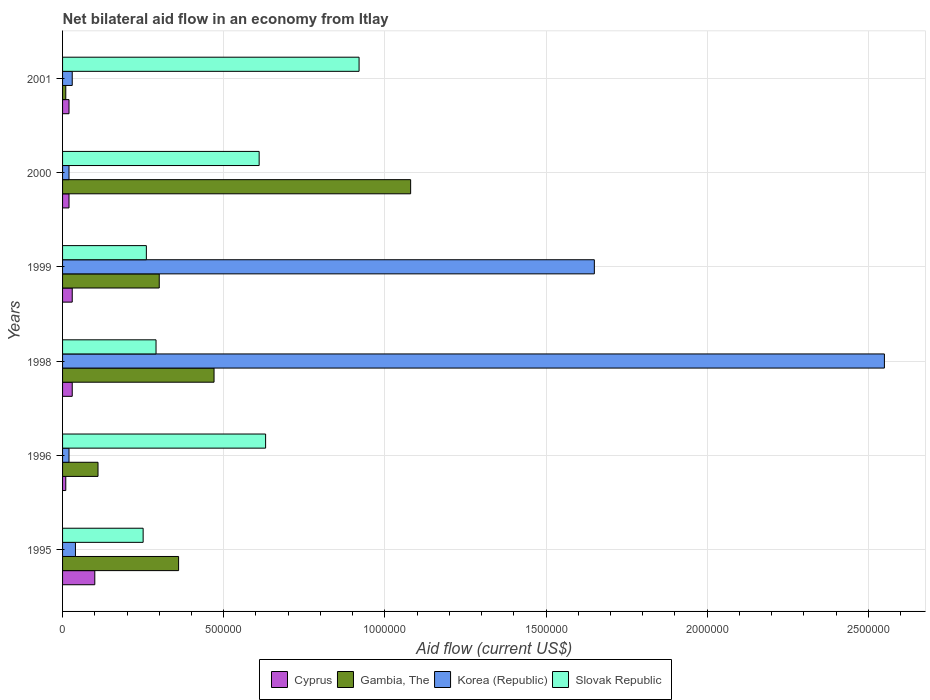How many groups of bars are there?
Make the answer very short. 6. Are the number of bars per tick equal to the number of legend labels?
Your answer should be very brief. Yes. What is the net bilateral aid flow in Cyprus in 1995?
Provide a short and direct response. 1.00e+05. Across all years, what is the maximum net bilateral aid flow in Slovak Republic?
Offer a terse response. 9.20e+05. In which year was the net bilateral aid flow in Korea (Republic) minimum?
Provide a short and direct response. 1996. What is the total net bilateral aid flow in Cyprus in the graph?
Keep it short and to the point. 2.10e+05. What is the difference between the net bilateral aid flow in Korea (Republic) in 1996 and that in 1998?
Your response must be concise. -2.53e+06. What is the difference between the net bilateral aid flow in Cyprus in 1998 and the net bilateral aid flow in Korea (Republic) in 1999?
Give a very brief answer. -1.62e+06. What is the average net bilateral aid flow in Korea (Republic) per year?
Keep it short and to the point. 7.18e+05. In the year 1996, what is the difference between the net bilateral aid flow in Cyprus and net bilateral aid flow in Gambia, The?
Your answer should be very brief. -1.00e+05. What is the difference between the highest and the lowest net bilateral aid flow in Gambia, The?
Offer a very short reply. 1.07e+06. In how many years, is the net bilateral aid flow in Slovak Republic greater than the average net bilateral aid flow in Slovak Republic taken over all years?
Offer a very short reply. 3. Is the sum of the net bilateral aid flow in Slovak Republic in 1996 and 1999 greater than the maximum net bilateral aid flow in Gambia, The across all years?
Your response must be concise. No. What does the 2nd bar from the top in 1995 represents?
Keep it short and to the point. Korea (Republic). What does the 4th bar from the bottom in 1995 represents?
Your answer should be very brief. Slovak Republic. How many bars are there?
Your answer should be compact. 24. Does the graph contain any zero values?
Give a very brief answer. No. Where does the legend appear in the graph?
Make the answer very short. Bottom center. How many legend labels are there?
Keep it short and to the point. 4. What is the title of the graph?
Your answer should be compact. Net bilateral aid flow in an economy from Itlay. What is the Aid flow (current US$) in Korea (Republic) in 1995?
Your answer should be very brief. 4.00e+04. What is the Aid flow (current US$) in Slovak Republic in 1995?
Make the answer very short. 2.50e+05. What is the Aid flow (current US$) in Cyprus in 1996?
Offer a very short reply. 10000. What is the Aid flow (current US$) in Korea (Republic) in 1996?
Give a very brief answer. 2.00e+04. What is the Aid flow (current US$) of Slovak Republic in 1996?
Offer a very short reply. 6.30e+05. What is the Aid flow (current US$) of Korea (Republic) in 1998?
Your answer should be compact. 2.55e+06. What is the Aid flow (current US$) in Slovak Republic in 1998?
Make the answer very short. 2.90e+05. What is the Aid flow (current US$) of Cyprus in 1999?
Offer a very short reply. 3.00e+04. What is the Aid flow (current US$) of Gambia, The in 1999?
Ensure brevity in your answer.  3.00e+05. What is the Aid flow (current US$) in Korea (Republic) in 1999?
Offer a terse response. 1.65e+06. What is the Aid flow (current US$) of Slovak Republic in 1999?
Provide a succinct answer. 2.60e+05. What is the Aid flow (current US$) in Cyprus in 2000?
Provide a short and direct response. 2.00e+04. What is the Aid flow (current US$) in Gambia, The in 2000?
Make the answer very short. 1.08e+06. What is the Aid flow (current US$) in Slovak Republic in 2000?
Your answer should be compact. 6.10e+05. What is the Aid flow (current US$) of Korea (Republic) in 2001?
Your answer should be compact. 3.00e+04. What is the Aid flow (current US$) of Slovak Republic in 2001?
Offer a very short reply. 9.20e+05. Across all years, what is the maximum Aid flow (current US$) in Cyprus?
Offer a terse response. 1.00e+05. Across all years, what is the maximum Aid flow (current US$) of Gambia, The?
Provide a succinct answer. 1.08e+06. Across all years, what is the maximum Aid flow (current US$) of Korea (Republic)?
Offer a terse response. 2.55e+06. Across all years, what is the maximum Aid flow (current US$) in Slovak Republic?
Offer a very short reply. 9.20e+05. Across all years, what is the minimum Aid flow (current US$) in Cyprus?
Your response must be concise. 10000. Across all years, what is the minimum Aid flow (current US$) of Gambia, The?
Provide a short and direct response. 10000. Across all years, what is the minimum Aid flow (current US$) of Slovak Republic?
Offer a terse response. 2.50e+05. What is the total Aid flow (current US$) in Cyprus in the graph?
Keep it short and to the point. 2.10e+05. What is the total Aid flow (current US$) in Gambia, The in the graph?
Your answer should be very brief. 2.33e+06. What is the total Aid flow (current US$) in Korea (Republic) in the graph?
Offer a very short reply. 4.31e+06. What is the total Aid flow (current US$) in Slovak Republic in the graph?
Ensure brevity in your answer.  2.96e+06. What is the difference between the Aid flow (current US$) in Cyprus in 1995 and that in 1996?
Give a very brief answer. 9.00e+04. What is the difference between the Aid flow (current US$) of Korea (Republic) in 1995 and that in 1996?
Your answer should be very brief. 2.00e+04. What is the difference between the Aid flow (current US$) in Slovak Republic in 1995 and that in 1996?
Make the answer very short. -3.80e+05. What is the difference between the Aid flow (current US$) in Cyprus in 1995 and that in 1998?
Give a very brief answer. 7.00e+04. What is the difference between the Aid flow (current US$) in Gambia, The in 1995 and that in 1998?
Your answer should be compact. -1.10e+05. What is the difference between the Aid flow (current US$) of Korea (Republic) in 1995 and that in 1998?
Your answer should be compact. -2.51e+06. What is the difference between the Aid flow (current US$) in Cyprus in 1995 and that in 1999?
Your answer should be very brief. 7.00e+04. What is the difference between the Aid flow (current US$) of Gambia, The in 1995 and that in 1999?
Your answer should be very brief. 6.00e+04. What is the difference between the Aid flow (current US$) of Korea (Republic) in 1995 and that in 1999?
Give a very brief answer. -1.61e+06. What is the difference between the Aid flow (current US$) of Slovak Republic in 1995 and that in 1999?
Ensure brevity in your answer.  -10000. What is the difference between the Aid flow (current US$) in Gambia, The in 1995 and that in 2000?
Provide a short and direct response. -7.20e+05. What is the difference between the Aid flow (current US$) in Korea (Republic) in 1995 and that in 2000?
Keep it short and to the point. 2.00e+04. What is the difference between the Aid flow (current US$) of Slovak Republic in 1995 and that in 2000?
Your answer should be very brief. -3.60e+05. What is the difference between the Aid flow (current US$) of Cyprus in 1995 and that in 2001?
Offer a very short reply. 8.00e+04. What is the difference between the Aid flow (current US$) of Gambia, The in 1995 and that in 2001?
Your answer should be very brief. 3.50e+05. What is the difference between the Aid flow (current US$) of Korea (Republic) in 1995 and that in 2001?
Provide a short and direct response. 10000. What is the difference between the Aid flow (current US$) in Slovak Republic in 1995 and that in 2001?
Provide a succinct answer. -6.70e+05. What is the difference between the Aid flow (current US$) of Cyprus in 1996 and that in 1998?
Give a very brief answer. -2.00e+04. What is the difference between the Aid flow (current US$) in Gambia, The in 1996 and that in 1998?
Offer a very short reply. -3.60e+05. What is the difference between the Aid flow (current US$) in Korea (Republic) in 1996 and that in 1998?
Keep it short and to the point. -2.53e+06. What is the difference between the Aid flow (current US$) in Korea (Republic) in 1996 and that in 1999?
Provide a succinct answer. -1.63e+06. What is the difference between the Aid flow (current US$) in Slovak Republic in 1996 and that in 1999?
Provide a short and direct response. 3.70e+05. What is the difference between the Aid flow (current US$) in Cyprus in 1996 and that in 2000?
Provide a short and direct response. -10000. What is the difference between the Aid flow (current US$) of Gambia, The in 1996 and that in 2000?
Make the answer very short. -9.70e+05. What is the difference between the Aid flow (current US$) in Korea (Republic) in 1996 and that in 2000?
Your answer should be compact. 0. What is the difference between the Aid flow (current US$) in Slovak Republic in 1996 and that in 2000?
Your answer should be compact. 2.00e+04. What is the difference between the Aid flow (current US$) of Cyprus in 1996 and that in 2001?
Provide a short and direct response. -10000. What is the difference between the Aid flow (current US$) in Gambia, The in 1996 and that in 2001?
Provide a succinct answer. 1.00e+05. What is the difference between the Aid flow (current US$) in Korea (Republic) in 1996 and that in 2001?
Your answer should be very brief. -10000. What is the difference between the Aid flow (current US$) of Gambia, The in 1998 and that in 1999?
Make the answer very short. 1.70e+05. What is the difference between the Aid flow (current US$) of Slovak Republic in 1998 and that in 1999?
Your answer should be very brief. 3.00e+04. What is the difference between the Aid flow (current US$) of Cyprus in 1998 and that in 2000?
Offer a terse response. 10000. What is the difference between the Aid flow (current US$) in Gambia, The in 1998 and that in 2000?
Your answer should be very brief. -6.10e+05. What is the difference between the Aid flow (current US$) in Korea (Republic) in 1998 and that in 2000?
Provide a short and direct response. 2.53e+06. What is the difference between the Aid flow (current US$) of Slovak Republic in 1998 and that in 2000?
Keep it short and to the point. -3.20e+05. What is the difference between the Aid flow (current US$) in Korea (Republic) in 1998 and that in 2001?
Provide a short and direct response. 2.52e+06. What is the difference between the Aid flow (current US$) in Slovak Republic in 1998 and that in 2001?
Provide a short and direct response. -6.30e+05. What is the difference between the Aid flow (current US$) in Cyprus in 1999 and that in 2000?
Provide a short and direct response. 10000. What is the difference between the Aid flow (current US$) of Gambia, The in 1999 and that in 2000?
Your answer should be very brief. -7.80e+05. What is the difference between the Aid flow (current US$) in Korea (Republic) in 1999 and that in 2000?
Ensure brevity in your answer.  1.63e+06. What is the difference between the Aid flow (current US$) of Slovak Republic in 1999 and that in 2000?
Offer a terse response. -3.50e+05. What is the difference between the Aid flow (current US$) of Cyprus in 1999 and that in 2001?
Your answer should be very brief. 10000. What is the difference between the Aid flow (current US$) in Gambia, The in 1999 and that in 2001?
Ensure brevity in your answer.  2.90e+05. What is the difference between the Aid flow (current US$) in Korea (Republic) in 1999 and that in 2001?
Your response must be concise. 1.62e+06. What is the difference between the Aid flow (current US$) in Slovak Republic in 1999 and that in 2001?
Ensure brevity in your answer.  -6.60e+05. What is the difference between the Aid flow (current US$) of Cyprus in 2000 and that in 2001?
Ensure brevity in your answer.  0. What is the difference between the Aid flow (current US$) in Gambia, The in 2000 and that in 2001?
Give a very brief answer. 1.07e+06. What is the difference between the Aid flow (current US$) in Slovak Republic in 2000 and that in 2001?
Your response must be concise. -3.10e+05. What is the difference between the Aid flow (current US$) of Cyprus in 1995 and the Aid flow (current US$) of Gambia, The in 1996?
Offer a terse response. -10000. What is the difference between the Aid flow (current US$) of Cyprus in 1995 and the Aid flow (current US$) of Korea (Republic) in 1996?
Your answer should be very brief. 8.00e+04. What is the difference between the Aid flow (current US$) of Cyprus in 1995 and the Aid flow (current US$) of Slovak Republic in 1996?
Your answer should be very brief. -5.30e+05. What is the difference between the Aid flow (current US$) of Gambia, The in 1995 and the Aid flow (current US$) of Korea (Republic) in 1996?
Provide a succinct answer. 3.40e+05. What is the difference between the Aid flow (current US$) of Korea (Republic) in 1995 and the Aid flow (current US$) of Slovak Republic in 1996?
Your response must be concise. -5.90e+05. What is the difference between the Aid flow (current US$) in Cyprus in 1995 and the Aid flow (current US$) in Gambia, The in 1998?
Offer a terse response. -3.70e+05. What is the difference between the Aid flow (current US$) of Cyprus in 1995 and the Aid flow (current US$) of Korea (Republic) in 1998?
Your answer should be very brief. -2.45e+06. What is the difference between the Aid flow (current US$) in Cyprus in 1995 and the Aid flow (current US$) in Slovak Republic in 1998?
Provide a short and direct response. -1.90e+05. What is the difference between the Aid flow (current US$) in Gambia, The in 1995 and the Aid flow (current US$) in Korea (Republic) in 1998?
Your answer should be compact. -2.19e+06. What is the difference between the Aid flow (current US$) of Gambia, The in 1995 and the Aid flow (current US$) of Slovak Republic in 1998?
Offer a very short reply. 7.00e+04. What is the difference between the Aid flow (current US$) in Korea (Republic) in 1995 and the Aid flow (current US$) in Slovak Republic in 1998?
Your answer should be very brief. -2.50e+05. What is the difference between the Aid flow (current US$) in Cyprus in 1995 and the Aid flow (current US$) in Gambia, The in 1999?
Make the answer very short. -2.00e+05. What is the difference between the Aid flow (current US$) in Cyprus in 1995 and the Aid flow (current US$) in Korea (Republic) in 1999?
Make the answer very short. -1.55e+06. What is the difference between the Aid flow (current US$) of Cyprus in 1995 and the Aid flow (current US$) of Slovak Republic in 1999?
Your response must be concise. -1.60e+05. What is the difference between the Aid flow (current US$) in Gambia, The in 1995 and the Aid flow (current US$) in Korea (Republic) in 1999?
Your answer should be very brief. -1.29e+06. What is the difference between the Aid flow (current US$) in Cyprus in 1995 and the Aid flow (current US$) in Gambia, The in 2000?
Your response must be concise. -9.80e+05. What is the difference between the Aid flow (current US$) of Cyprus in 1995 and the Aid flow (current US$) of Slovak Republic in 2000?
Provide a succinct answer. -5.10e+05. What is the difference between the Aid flow (current US$) of Gambia, The in 1995 and the Aid flow (current US$) of Korea (Republic) in 2000?
Make the answer very short. 3.40e+05. What is the difference between the Aid flow (current US$) of Korea (Republic) in 1995 and the Aid flow (current US$) of Slovak Republic in 2000?
Provide a short and direct response. -5.70e+05. What is the difference between the Aid flow (current US$) of Cyprus in 1995 and the Aid flow (current US$) of Korea (Republic) in 2001?
Ensure brevity in your answer.  7.00e+04. What is the difference between the Aid flow (current US$) of Cyprus in 1995 and the Aid flow (current US$) of Slovak Republic in 2001?
Offer a very short reply. -8.20e+05. What is the difference between the Aid flow (current US$) in Gambia, The in 1995 and the Aid flow (current US$) in Slovak Republic in 2001?
Make the answer very short. -5.60e+05. What is the difference between the Aid flow (current US$) in Korea (Republic) in 1995 and the Aid flow (current US$) in Slovak Republic in 2001?
Your response must be concise. -8.80e+05. What is the difference between the Aid flow (current US$) in Cyprus in 1996 and the Aid flow (current US$) in Gambia, The in 1998?
Your answer should be very brief. -4.60e+05. What is the difference between the Aid flow (current US$) of Cyprus in 1996 and the Aid flow (current US$) of Korea (Republic) in 1998?
Ensure brevity in your answer.  -2.54e+06. What is the difference between the Aid flow (current US$) in Cyprus in 1996 and the Aid flow (current US$) in Slovak Republic in 1998?
Offer a terse response. -2.80e+05. What is the difference between the Aid flow (current US$) in Gambia, The in 1996 and the Aid flow (current US$) in Korea (Republic) in 1998?
Your response must be concise. -2.44e+06. What is the difference between the Aid flow (current US$) of Gambia, The in 1996 and the Aid flow (current US$) of Slovak Republic in 1998?
Provide a short and direct response. -1.80e+05. What is the difference between the Aid flow (current US$) of Cyprus in 1996 and the Aid flow (current US$) of Gambia, The in 1999?
Ensure brevity in your answer.  -2.90e+05. What is the difference between the Aid flow (current US$) of Cyprus in 1996 and the Aid flow (current US$) of Korea (Republic) in 1999?
Your response must be concise. -1.64e+06. What is the difference between the Aid flow (current US$) in Gambia, The in 1996 and the Aid flow (current US$) in Korea (Republic) in 1999?
Your response must be concise. -1.54e+06. What is the difference between the Aid flow (current US$) in Korea (Republic) in 1996 and the Aid flow (current US$) in Slovak Republic in 1999?
Provide a short and direct response. -2.40e+05. What is the difference between the Aid flow (current US$) of Cyprus in 1996 and the Aid flow (current US$) of Gambia, The in 2000?
Your answer should be compact. -1.07e+06. What is the difference between the Aid flow (current US$) of Cyprus in 1996 and the Aid flow (current US$) of Korea (Republic) in 2000?
Offer a very short reply. -10000. What is the difference between the Aid flow (current US$) of Cyprus in 1996 and the Aid flow (current US$) of Slovak Republic in 2000?
Your response must be concise. -6.00e+05. What is the difference between the Aid flow (current US$) of Gambia, The in 1996 and the Aid flow (current US$) of Korea (Republic) in 2000?
Make the answer very short. 9.00e+04. What is the difference between the Aid flow (current US$) of Gambia, The in 1996 and the Aid flow (current US$) of Slovak Republic in 2000?
Offer a very short reply. -5.00e+05. What is the difference between the Aid flow (current US$) in Korea (Republic) in 1996 and the Aid flow (current US$) in Slovak Republic in 2000?
Provide a succinct answer. -5.90e+05. What is the difference between the Aid flow (current US$) of Cyprus in 1996 and the Aid flow (current US$) of Gambia, The in 2001?
Ensure brevity in your answer.  0. What is the difference between the Aid flow (current US$) in Cyprus in 1996 and the Aid flow (current US$) in Slovak Republic in 2001?
Offer a terse response. -9.10e+05. What is the difference between the Aid flow (current US$) of Gambia, The in 1996 and the Aid flow (current US$) of Korea (Republic) in 2001?
Provide a short and direct response. 8.00e+04. What is the difference between the Aid flow (current US$) in Gambia, The in 1996 and the Aid flow (current US$) in Slovak Republic in 2001?
Your answer should be very brief. -8.10e+05. What is the difference between the Aid flow (current US$) in Korea (Republic) in 1996 and the Aid flow (current US$) in Slovak Republic in 2001?
Your response must be concise. -9.00e+05. What is the difference between the Aid flow (current US$) of Cyprus in 1998 and the Aid flow (current US$) of Korea (Republic) in 1999?
Your response must be concise. -1.62e+06. What is the difference between the Aid flow (current US$) of Gambia, The in 1998 and the Aid flow (current US$) of Korea (Republic) in 1999?
Provide a succinct answer. -1.18e+06. What is the difference between the Aid flow (current US$) in Korea (Republic) in 1998 and the Aid flow (current US$) in Slovak Republic in 1999?
Provide a succinct answer. 2.29e+06. What is the difference between the Aid flow (current US$) of Cyprus in 1998 and the Aid flow (current US$) of Gambia, The in 2000?
Provide a succinct answer. -1.05e+06. What is the difference between the Aid flow (current US$) in Cyprus in 1998 and the Aid flow (current US$) in Slovak Republic in 2000?
Offer a terse response. -5.80e+05. What is the difference between the Aid flow (current US$) of Gambia, The in 1998 and the Aid flow (current US$) of Korea (Republic) in 2000?
Keep it short and to the point. 4.50e+05. What is the difference between the Aid flow (current US$) of Korea (Republic) in 1998 and the Aid flow (current US$) of Slovak Republic in 2000?
Provide a succinct answer. 1.94e+06. What is the difference between the Aid flow (current US$) in Cyprus in 1998 and the Aid flow (current US$) in Gambia, The in 2001?
Your answer should be very brief. 2.00e+04. What is the difference between the Aid flow (current US$) in Cyprus in 1998 and the Aid flow (current US$) in Korea (Republic) in 2001?
Make the answer very short. 0. What is the difference between the Aid flow (current US$) in Cyprus in 1998 and the Aid flow (current US$) in Slovak Republic in 2001?
Give a very brief answer. -8.90e+05. What is the difference between the Aid flow (current US$) of Gambia, The in 1998 and the Aid flow (current US$) of Korea (Republic) in 2001?
Your answer should be very brief. 4.40e+05. What is the difference between the Aid flow (current US$) in Gambia, The in 1998 and the Aid flow (current US$) in Slovak Republic in 2001?
Provide a short and direct response. -4.50e+05. What is the difference between the Aid flow (current US$) of Korea (Republic) in 1998 and the Aid flow (current US$) of Slovak Republic in 2001?
Keep it short and to the point. 1.63e+06. What is the difference between the Aid flow (current US$) in Cyprus in 1999 and the Aid flow (current US$) in Gambia, The in 2000?
Your answer should be very brief. -1.05e+06. What is the difference between the Aid flow (current US$) in Cyprus in 1999 and the Aid flow (current US$) in Korea (Republic) in 2000?
Your response must be concise. 10000. What is the difference between the Aid flow (current US$) of Cyprus in 1999 and the Aid flow (current US$) of Slovak Republic in 2000?
Offer a terse response. -5.80e+05. What is the difference between the Aid flow (current US$) in Gambia, The in 1999 and the Aid flow (current US$) in Korea (Republic) in 2000?
Your answer should be compact. 2.80e+05. What is the difference between the Aid flow (current US$) in Gambia, The in 1999 and the Aid flow (current US$) in Slovak Republic in 2000?
Make the answer very short. -3.10e+05. What is the difference between the Aid flow (current US$) of Korea (Republic) in 1999 and the Aid flow (current US$) of Slovak Republic in 2000?
Offer a terse response. 1.04e+06. What is the difference between the Aid flow (current US$) in Cyprus in 1999 and the Aid flow (current US$) in Gambia, The in 2001?
Your answer should be compact. 2.00e+04. What is the difference between the Aid flow (current US$) in Cyprus in 1999 and the Aid flow (current US$) in Slovak Republic in 2001?
Give a very brief answer. -8.90e+05. What is the difference between the Aid flow (current US$) of Gambia, The in 1999 and the Aid flow (current US$) of Slovak Republic in 2001?
Provide a short and direct response. -6.20e+05. What is the difference between the Aid flow (current US$) of Korea (Republic) in 1999 and the Aid flow (current US$) of Slovak Republic in 2001?
Make the answer very short. 7.30e+05. What is the difference between the Aid flow (current US$) of Cyprus in 2000 and the Aid flow (current US$) of Gambia, The in 2001?
Your response must be concise. 10000. What is the difference between the Aid flow (current US$) in Cyprus in 2000 and the Aid flow (current US$) in Korea (Republic) in 2001?
Provide a succinct answer. -10000. What is the difference between the Aid flow (current US$) in Cyprus in 2000 and the Aid flow (current US$) in Slovak Republic in 2001?
Keep it short and to the point. -9.00e+05. What is the difference between the Aid flow (current US$) in Gambia, The in 2000 and the Aid flow (current US$) in Korea (Republic) in 2001?
Offer a very short reply. 1.05e+06. What is the difference between the Aid flow (current US$) of Korea (Republic) in 2000 and the Aid flow (current US$) of Slovak Republic in 2001?
Offer a very short reply. -9.00e+05. What is the average Aid flow (current US$) of Cyprus per year?
Keep it short and to the point. 3.50e+04. What is the average Aid flow (current US$) of Gambia, The per year?
Your response must be concise. 3.88e+05. What is the average Aid flow (current US$) in Korea (Republic) per year?
Give a very brief answer. 7.18e+05. What is the average Aid flow (current US$) in Slovak Republic per year?
Give a very brief answer. 4.93e+05. In the year 1995, what is the difference between the Aid flow (current US$) of Cyprus and Aid flow (current US$) of Korea (Republic)?
Offer a very short reply. 6.00e+04. In the year 1995, what is the difference between the Aid flow (current US$) in Cyprus and Aid flow (current US$) in Slovak Republic?
Give a very brief answer. -1.50e+05. In the year 1995, what is the difference between the Aid flow (current US$) of Gambia, The and Aid flow (current US$) of Korea (Republic)?
Give a very brief answer. 3.20e+05. In the year 1996, what is the difference between the Aid flow (current US$) of Cyprus and Aid flow (current US$) of Gambia, The?
Offer a terse response. -1.00e+05. In the year 1996, what is the difference between the Aid flow (current US$) of Cyprus and Aid flow (current US$) of Korea (Republic)?
Provide a short and direct response. -10000. In the year 1996, what is the difference between the Aid flow (current US$) of Cyprus and Aid flow (current US$) of Slovak Republic?
Your response must be concise. -6.20e+05. In the year 1996, what is the difference between the Aid flow (current US$) of Gambia, The and Aid flow (current US$) of Korea (Republic)?
Offer a terse response. 9.00e+04. In the year 1996, what is the difference between the Aid flow (current US$) of Gambia, The and Aid flow (current US$) of Slovak Republic?
Provide a succinct answer. -5.20e+05. In the year 1996, what is the difference between the Aid flow (current US$) of Korea (Republic) and Aid flow (current US$) of Slovak Republic?
Your answer should be very brief. -6.10e+05. In the year 1998, what is the difference between the Aid flow (current US$) in Cyprus and Aid flow (current US$) in Gambia, The?
Make the answer very short. -4.40e+05. In the year 1998, what is the difference between the Aid flow (current US$) in Cyprus and Aid flow (current US$) in Korea (Republic)?
Make the answer very short. -2.52e+06. In the year 1998, what is the difference between the Aid flow (current US$) in Gambia, The and Aid flow (current US$) in Korea (Republic)?
Your answer should be compact. -2.08e+06. In the year 1998, what is the difference between the Aid flow (current US$) of Gambia, The and Aid flow (current US$) of Slovak Republic?
Your answer should be compact. 1.80e+05. In the year 1998, what is the difference between the Aid flow (current US$) in Korea (Republic) and Aid flow (current US$) in Slovak Republic?
Offer a terse response. 2.26e+06. In the year 1999, what is the difference between the Aid flow (current US$) of Cyprus and Aid flow (current US$) of Korea (Republic)?
Offer a very short reply. -1.62e+06. In the year 1999, what is the difference between the Aid flow (current US$) of Gambia, The and Aid flow (current US$) of Korea (Republic)?
Ensure brevity in your answer.  -1.35e+06. In the year 1999, what is the difference between the Aid flow (current US$) of Gambia, The and Aid flow (current US$) of Slovak Republic?
Give a very brief answer. 4.00e+04. In the year 1999, what is the difference between the Aid flow (current US$) of Korea (Republic) and Aid flow (current US$) of Slovak Republic?
Keep it short and to the point. 1.39e+06. In the year 2000, what is the difference between the Aid flow (current US$) in Cyprus and Aid flow (current US$) in Gambia, The?
Your response must be concise. -1.06e+06. In the year 2000, what is the difference between the Aid flow (current US$) of Cyprus and Aid flow (current US$) of Korea (Republic)?
Keep it short and to the point. 0. In the year 2000, what is the difference between the Aid flow (current US$) in Cyprus and Aid flow (current US$) in Slovak Republic?
Offer a terse response. -5.90e+05. In the year 2000, what is the difference between the Aid flow (current US$) in Gambia, The and Aid flow (current US$) in Korea (Republic)?
Offer a very short reply. 1.06e+06. In the year 2000, what is the difference between the Aid flow (current US$) in Gambia, The and Aid flow (current US$) in Slovak Republic?
Offer a terse response. 4.70e+05. In the year 2000, what is the difference between the Aid flow (current US$) in Korea (Republic) and Aid flow (current US$) in Slovak Republic?
Keep it short and to the point. -5.90e+05. In the year 2001, what is the difference between the Aid flow (current US$) in Cyprus and Aid flow (current US$) in Gambia, The?
Provide a succinct answer. 10000. In the year 2001, what is the difference between the Aid flow (current US$) in Cyprus and Aid flow (current US$) in Korea (Republic)?
Your response must be concise. -10000. In the year 2001, what is the difference between the Aid flow (current US$) in Cyprus and Aid flow (current US$) in Slovak Republic?
Give a very brief answer. -9.00e+05. In the year 2001, what is the difference between the Aid flow (current US$) in Gambia, The and Aid flow (current US$) in Slovak Republic?
Your answer should be very brief. -9.10e+05. In the year 2001, what is the difference between the Aid flow (current US$) of Korea (Republic) and Aid flow (current US$) of Slovak Republic?
Give a very brief answer. -8.90e+05. What is the ratio of the Aid flow (current US$) in Gambia, The in 1995 to that in 1996?
Offer a terse response. 3.27. What is the ratio of the Aid flow (current US$) in Korea (Republic) in 1995 to that in 1996?
Make the answer very short. 2. What is the ratio of the Aid flow (current US$) of Slovak Republic in 1995 to that in 1996?
Keep it short and to the point. 0.4. What is the ratio of the Aid flow (current US$) of Cyprus in 1995 to that in 1998?
Keep it short and to the point. 3.33. What is the ratio of the Aid flow (current US$) of Gambia, The in 1995 to that in 1998?
Make the answer very short. 0.77. What is the ratio of the Aid flow (current US$) in Korea (Republic) in 1995 to that in 1998?
Your answer should be very brief. 0.02. What is the ratio of the Aid flow (current US$) in Slovak Republic in 1995 to that in 1998?
Provide a short and direct response. 0.86. What is the ratio of the Aid flow (current US$) in Cyprus in 1995 to that in 1999?
Offer a very short reply. 3.33. What is the ratio of the Aid flow (current US$) of Korea (Republic) in 1995 to that in 1999?
Ensure brevity in your answer.  0.02. What is the ratio of the Aid flow (current US$) in Slovak Republic in 1995 to that in 1999?
Offer a very short reply. 0.96. What is the ratio of the Aid flow (current US$) of Cyprus in 1995 to that in 2000?
Offer a terse response. 5. What is the ratio of the Aid flow (current US$) of Slovak Republic in 1995 to that in 2000?
Provide a short and direct response. 0.41. What is the ratio of the Aid flow (current US$) in Korea (Republic) in 1995 to that in 2001?
Ensure brevity in your answer.  1.33. What is the ratio of the Aid flow (current US$) of Slovak Republic in 1995 to that in 2001?
Your answer should be compact. 0.27. What is the ratio of the Aid flow (current US$) in Cyprus in 1996 to that in 1998?
Your answer should be compact. 0.33. What is the ratio of the Aid flow (current US$) in Gambia, The in 1996 to that in 1998?
Give a very brief answer. 0.23. What is the ratio of the Aid flow (current US$) of Korea (Republic) in 1996 to that in 1998?
Your answer should be compact. 0.01. What is the ratio of the Aid flow (current US$) in Slovak Republic in 1996 to that in 1998?
Give a very brief answer. 2.17. What is the ratio of the Aid flow (current US$) in Gambia, The in 1996 to that in 1999?
Ensure brevity in your answer.  0.37. What is the ratio of the Aid flow (current US$) in Korea (Republic) in 1996 to that in 1999?
Provide a short and direct response. 0.01. What is the ratio of the Aid flow (current US$) in Slovak Republic in 1996 to that in 1999?
Provide a succinct answer. 2.42. What is the ratio of the Aid flow (current US$) of Cyprus in 1996 to that in 2000?
Provide a short and direct response. 0.5. What is the ratio of the Aid flow (current US$) in Gambia, The in 1996 to that in 2000?
Offer a terse response. 0.1. What is the ratio of the Aid flow (current US$) in Korea (Republic) in 1996 to that in 2000?
Offer a very short reply. 1. What is the ratio of the Aid flow (current US$) of Slovak Republic in 1996 to that in 2000?
Provide a succinct answer. 1.03. What is the ratio of the Aid flow (current US$) in Slovak Republic in 1996 to that in 2001?
Your answer should be compact. 0.68. What is the ratio of the Aid flow (current US$) in Cyprus in 1998 to that in 1999?
Make the answer very short. 1. What is the ratio of the Aid flow (current US$) of Gambia, The in 1998 to that in 1999?
Ensure brevity in your answer.  1.57. What is the ratio of the Aid flow (current US$) in Korea (Republic) in 1998 to that in 1999?
Provide a short and direct response. 1.55. What is the ratio of the Aid flow (current US$) in Slovak Republic in 1998 to that in 1999?
Provide a short and direct response. 1.12. What is the ratio of the Aid flow (current US$) of Cyprus in 1998 to that in 2000?
Ensure brevity in your answer.  1.5. What is the ratio of the Aid flow (current US$) in Gambia, The in 1998 to that in 2000?
Provide a succinct answer. 0.44. What is the ratio of the Aid flow (current US$) of Korea (Republic) in 1998 to that in 2000?
Your response must be concise. 127.5. What is the ratio of the Aid flow (current US$) of Slovak Republic in 1998 to that in 2000?
Provide a succinct answer. 0.48. What is the ratio of the Aid flow (current US$) of Cyprus in 1998 to that in 2001?
Offer a very short reply. 1.5. What is the ratio of the Aid flow (current US$) of Gambia, The in 1998 to that in 2001?
Provide a short and direct response. 47. What is the ratio of the Aid flow (current US$) in Slovak Republic in 1998 to that in 2001?
Offer a terse response. 0.32. What is the ratio of the Aid flow (current US$) in Cyprus in 1999 to that in 2000?
Keep it short and to the point. 1.5. What is the ratio of the Aid flow (current US$) in Gambia, The in 1999 to that in 2000?
Your answer should be very brief. 0.28. What is the ratio of the Aid flow (current US$) in Korea (Republic) in 1999 to that in 2000?
Provide a short and direct response. 82.5. What is the ratio of the Aid flow (current US$) of Slovak Republic in 1999 to that in 2000?
Offer a very short reply. 0.43. What is the ratio of the Aid flow (current US$) in Gambia, The in 1999 to that in 2001?
Ensure brevity in your answer.  30. What is the ratio of the Aid flow (current US$) of Korea (Republic) in 1999 to that in 2001?
Keep it short and to the point. 55. What is the ratio of the Aid flow (current US$) in Slovak Republic in 1999 to that in 2001?
Your answer should be compact. 0.28. What is the ratio of the Aid flow (current US$) in Cyprus in 2000 to that in 2001?
Provide a short and direct response. 1. What is the ratio of the Aid flow (current US$) of Gambia, The in 2000 to that in 2001?
Your answer should be very brief. 108. What is the ratio of the Aid flow (current US$) in Slovak Republic in 2000 to that in 2001?
Your answer should be very brief. 0.66. What is the difference between the highest and the second highest Aid flow (current US$) of Cyprus?
Ensure brevity in your answer.  7.00e+04. What is the difference between the highest and the second highest Aid flow (current US$) in Korea (Republic)?
Provide a short and direct response. 9.00e+05. What is the difference between the highest and the second highest Aid flow (current US$) in Slovak Republic?
Your response must be concise. 2.90e+05. What is the difference between the highest and the lowest Aid flow (current US$) in Cyprus?
Ensure brevity in your answer.  9.00e+04. What is the difference between the highest and the lowest Aid flow (current US$) of Gambia, The?
Your answer should be compact. 1.07e+06. What is the difference between the highest and the lowest Aid flow (current US$) of Korea (Republic)?
Your response must be concise. 2.53e+06. What is the difference between the highest and the lowest Aid flow (current US$) of Slovak Republic?
Offer a very short reply. 6.70e+05. 